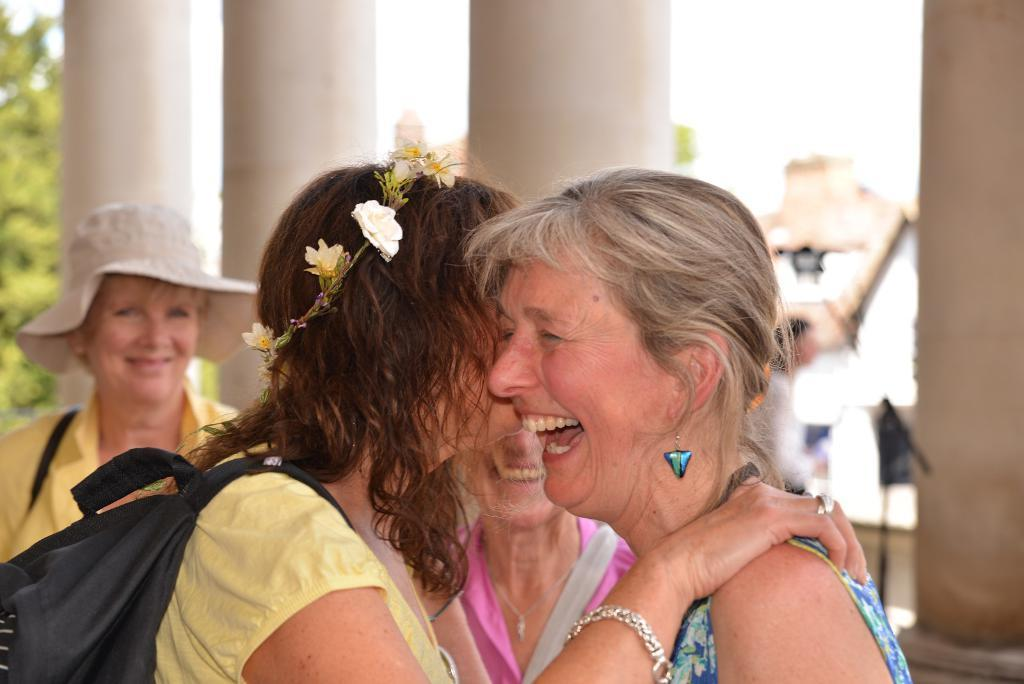What is the woman in the image wearing? The woman is wearing a crown and carrying a bag in the image. How is the other woman in the image depicted? The other woman is smiling in the image. Can you describe the background of the image? The background of the image is blurry, but pillars, a tree, and people are visible. What type of copper object can be seen in the woman's hand in the image? There is no copper object present in the woman's hand in the image. What is the occupation of the secretary in the image? There is no secretary present in the image. 